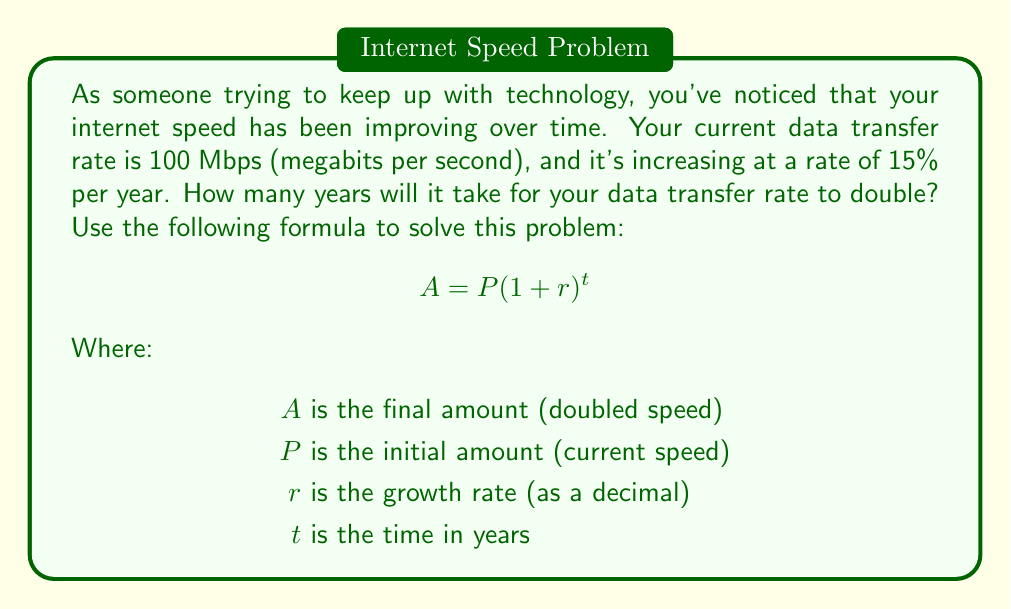Solve this math problem. Let's approach this step-by-step:

1) We know that:
   $P = 100$ Mbps (initial speed)
   $r = 0.15$ (15% written as a decimal)
   $A = 2P = 200$ Mbps (doubled speed)

2) We need to find $t$. Let's substitute these values into the formula:

   $$ 200 = 100(1 + 0.15)^t $$

3) Simplify:
   $$ 2 = (1.15)^t $$

4) To solve for $t$, we need to use logarithms. Let's apply the natural log (ln) to both sides:

   $$ \ln(2) = \ln((1.15)^t) $$

5) Using the logarithm property $\ln(a^b) = b\ln(a)$, we get:

   $$ \ln(2) = t\ln(1.15) $$

6) Now we can solve for $t$:

   $$ t = \frac{\ln(2)}{\ln(1.15)} $$

7) Using a calculator (or computer):

   $$ t \approx 4.96 \text{ years} $$
Answer: It will take approximately 4.96 years for the data transfer rate to double. 